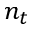<formula> <loc_0><loc_0><loc_500><loc_500>n _ { t }</formula> 